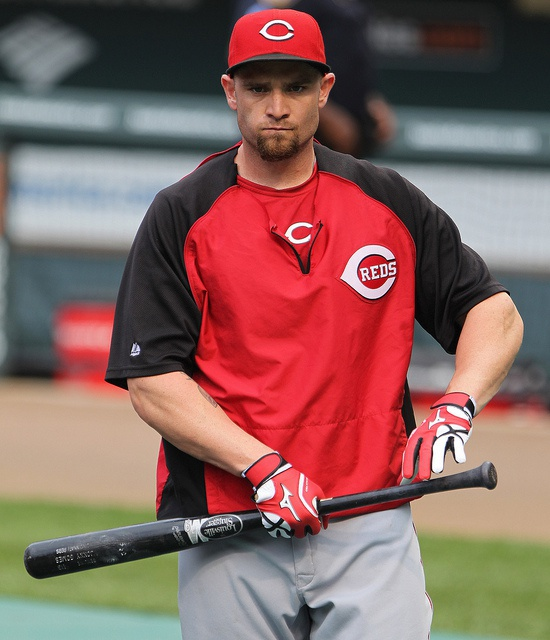Describe the objects in this image and their specific colors. I can see people in black, red, and darkgray tones, baseball bat in black, gray, and darkgray tones, people in black, maroon, and brown tones, baseball glove in black, salmon, white, and red tones, and baseball glove in black, salmon, white, and gray tones in this image. 